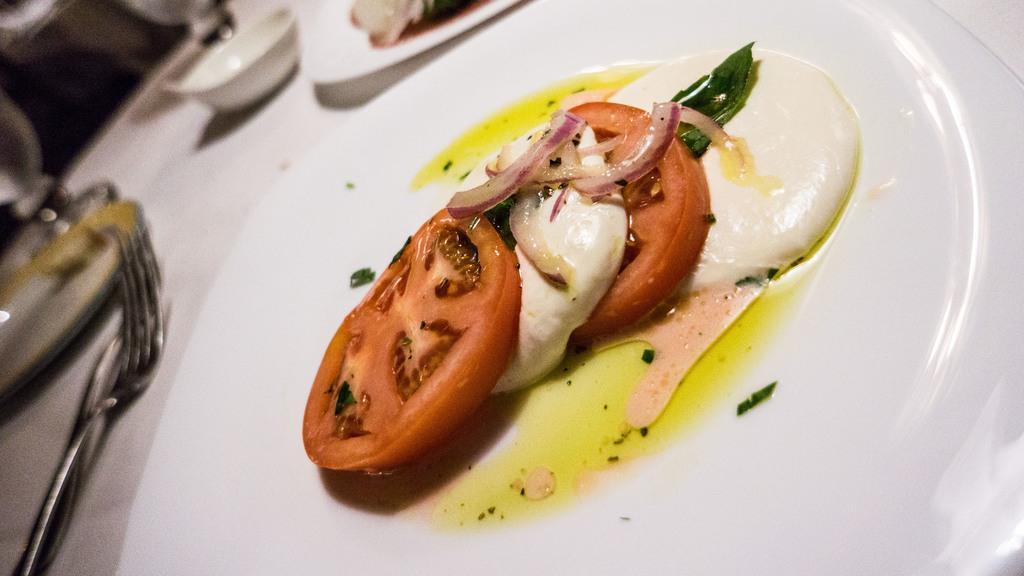Could you give a brief overview of what you see in this image? In the image we can see a table, on the table there are some plates, food, cups, fork, spoon, glass. 